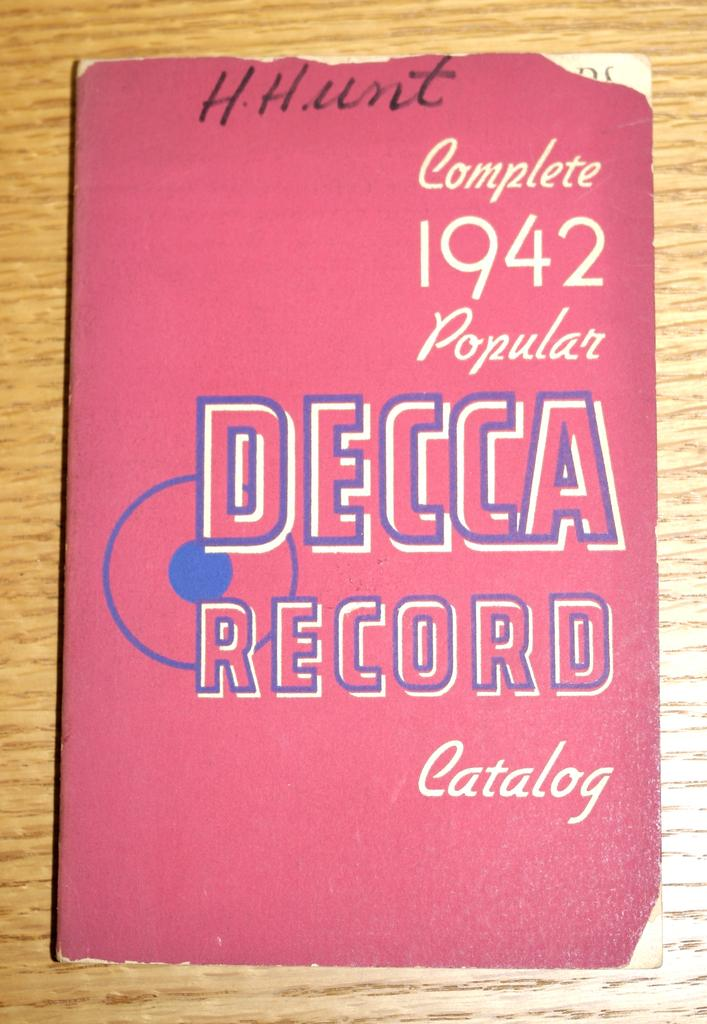<image>
Create a compact narrative representing the image presented. The Decca Record catalog, complete 1942 popular version. 